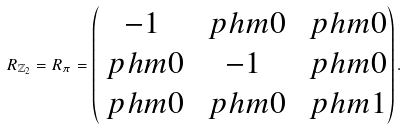<formula> <loc_0><loc_0><loc_500><loc_500>R _ { \mathbb { Z } _ { 2 } } = R _ { \pi } = \begin{pmatrix} - 1 & \ p h m 0 & \ p h m 0 \\ \ p h m 0 & - 1 & \ p h m 0 \\ \ p h m 0 & \ p h m 0 & \ p h m 1 \end{pmatrix} .</formula> 